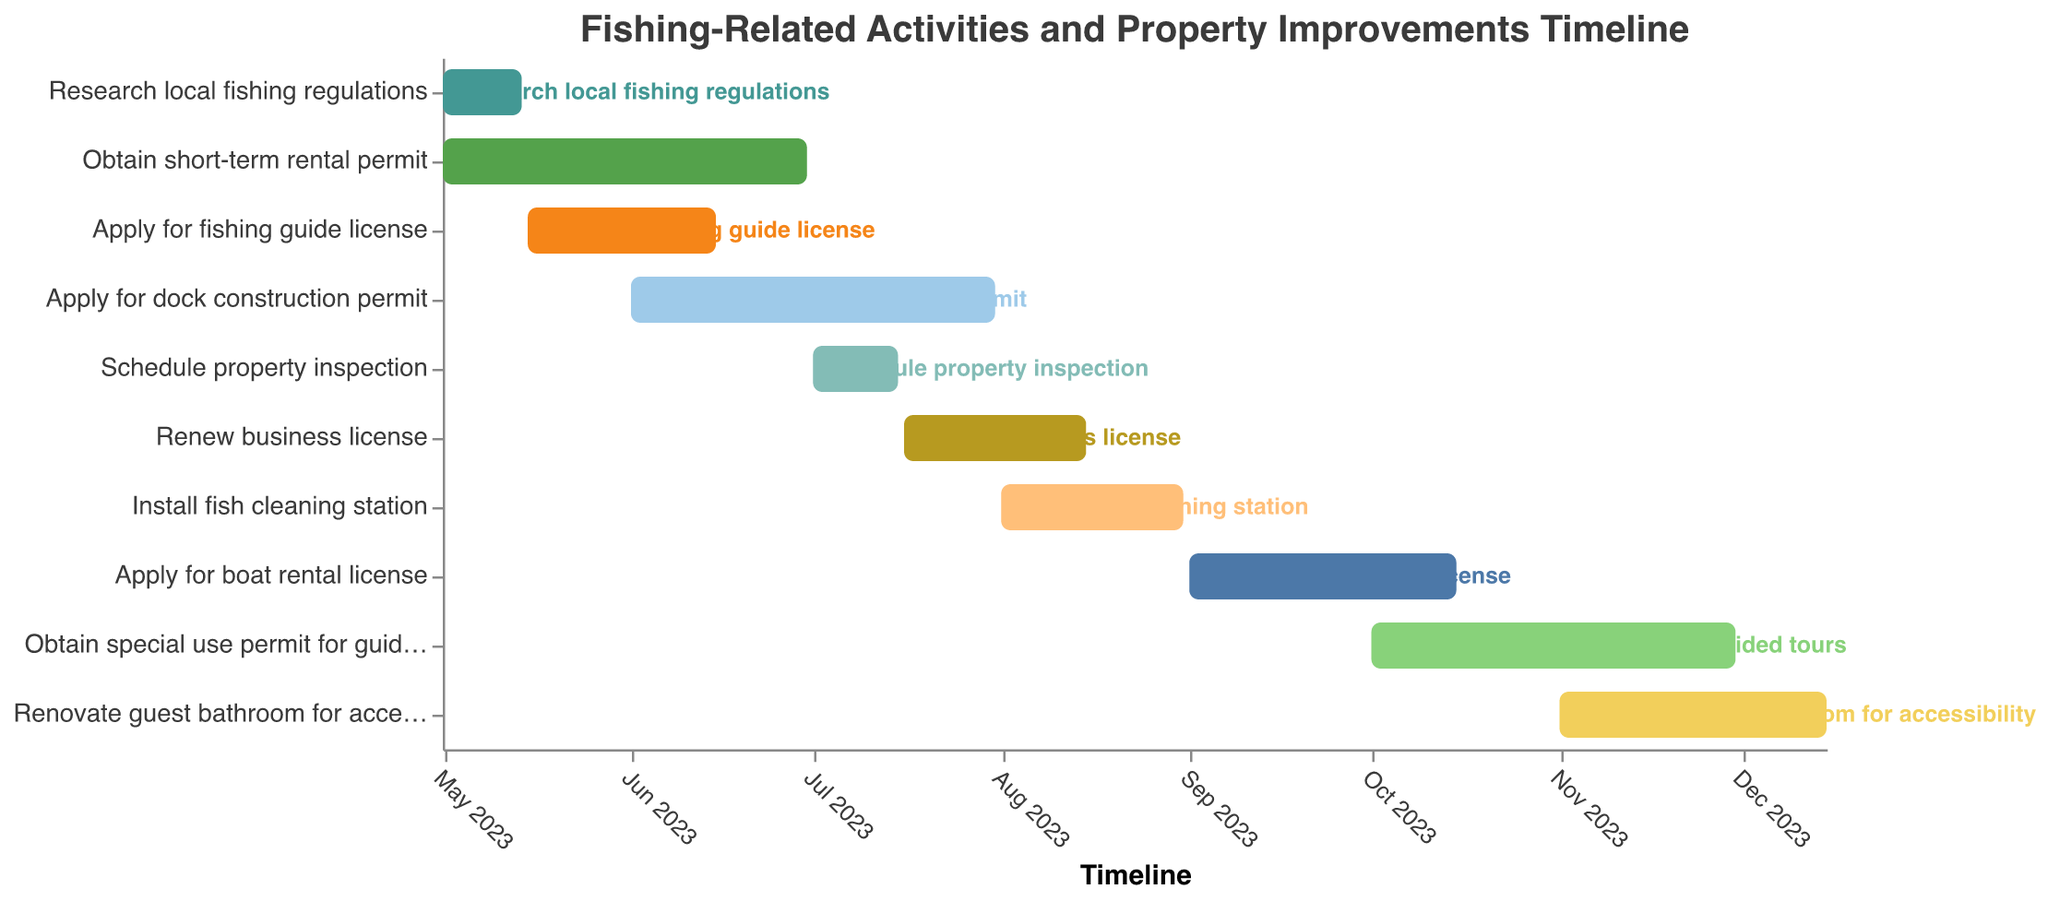What's the title of the Gantt Chart? The title is displayed at the top of the Gantt Chart. The title provides an overview of what the chart represents.
Answer: "Fishing-Related Activities and Property Improvements Timeline" When does the task "Apply for fishing guide license" start and end? Locate the bar named "Apply for fishing guide license" and identify the dates at the start and end points of this bar.
Answer: Start: 2023-05-15, End: 2023-06-15 Which task has the shortest duration, and how long is it? Compare the durations of all tasks by looking at the length of each bar. The shortest one has the least time between start and end dates.
Answer: Schedule property inspection, 15 days Which task spans the longest period of time? Compare the lengths of the bars for each task to see which one is the longest. The longest bar represents the task that spans the longest period of time.
Answer: Obtain short-term rental permit How many tasks begin in May 2023? Check the bars that have their start dates in the month of May 2023 and count the number of such tasks.
Answer: 3 tasks Which two tasks overlap during June 2023? Identify the bars that intersect or overlap within the timeframe of June 2023.
Answer: Apply for fishing guide license and Obtain short-term rental permit Are there any tasks that start and end within the same month? If so, which ones? Look for bars where both the start date and end date fall within the same month.
Answer: Research local fishing regulations and Schedule property inspection How long after "Apply for boat rental license" does "Obtain special use permit for guided tours" start? Find the end date of "Apply for boat rental license" and the start date of "Obtain special use permit for guided tours," then calculate the number of days between these dates.
Answer: 15 days Between which dates should you install a fish cleaning station? Locate the bar labeled "Install fish cleaning station" and identify its start and end dates.
Answer: Start: 2023-08-01, End: 2023-08-31 During which month do the highest number of tasks start? Check the start dates of each task and see which month has the highest frequency of starting tasks.
Answer: May 2023 